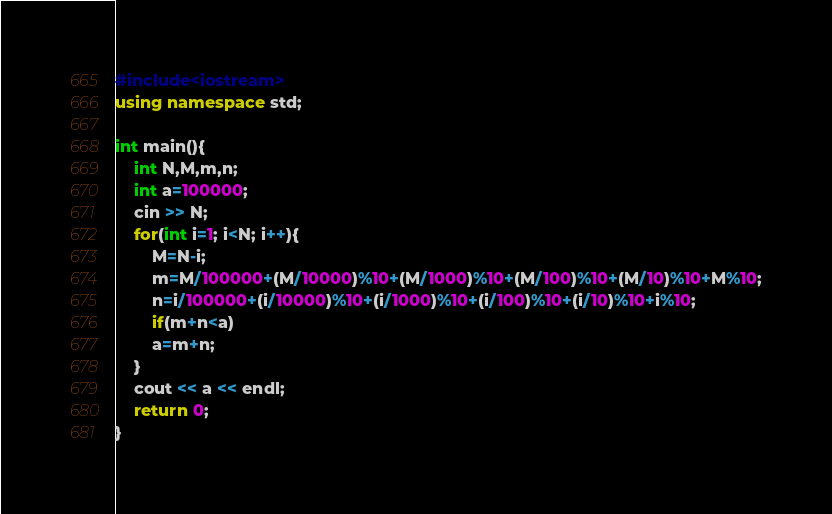Convert code to text. <code><loc_0><loc_0><loc_500><loc_500><_C++_>#include<iostream>
using namespace std;

int main(){
    int N,M,m,n;
    int a=100000;
    cin >> N;
    for(int i=1; i<N; i++){
        M=N-i;
        m=M/100000+(M/10000)%10+(M/1000)%10+(M/100)%10+(M/10)%10+M%10;
        n=i/100000+(i/10000)%10+(i/1000)%10+(i/100)%10+(i/10)%10+i%10;
        if(m+n<a)
        a=m+n;
    }
    cout << a << endl;
    return 0;
}
</code> 